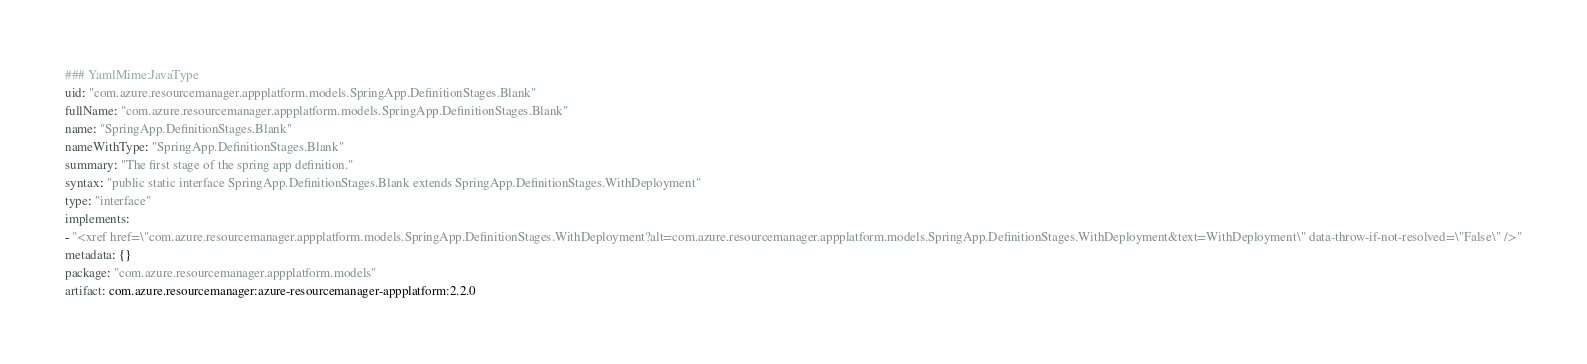<code> <loc_0><loc_0><loc_500><loc_500><_YAML_>### YamlMime:JavaType
uid: "com.azure.resourcemanager.appplatform.models.SpringApp.DefinitionStages.Blank"
fullName: "com.azure.resourcemanager.appplatform.models.SpringApp.DefinitionStages.Blank"
name: "SpringApp.DefinitionStages.Blank"
nameWithType: "SpringApp.DefinitionStages.Blank"
summary: "The first stage of the spring app definition."
syntax: "public static interface SpringApp.DefinitionStages.Blank extends SpringApp.DefinitionStages.WithDeployment"
type: "interface"
implements:
- "<xref href=\"com.azure.resourcemanager.appplatform.models.SpringApp.DefinitionStages.WithDeployment?alt=com.azure.resourcemanager.appplatform.models.SpringApp.DefinitionStages.WithDeployment&text=WithDeployment\" data-throw-if-not-resolved=\"False\" />"
metadata: {}
package: "com.azure.resourcemanager.appplatform.models"
artifact: com.azure.resourcemanager:azure-resourcemanager-appplatform:2.2.0
</code> 